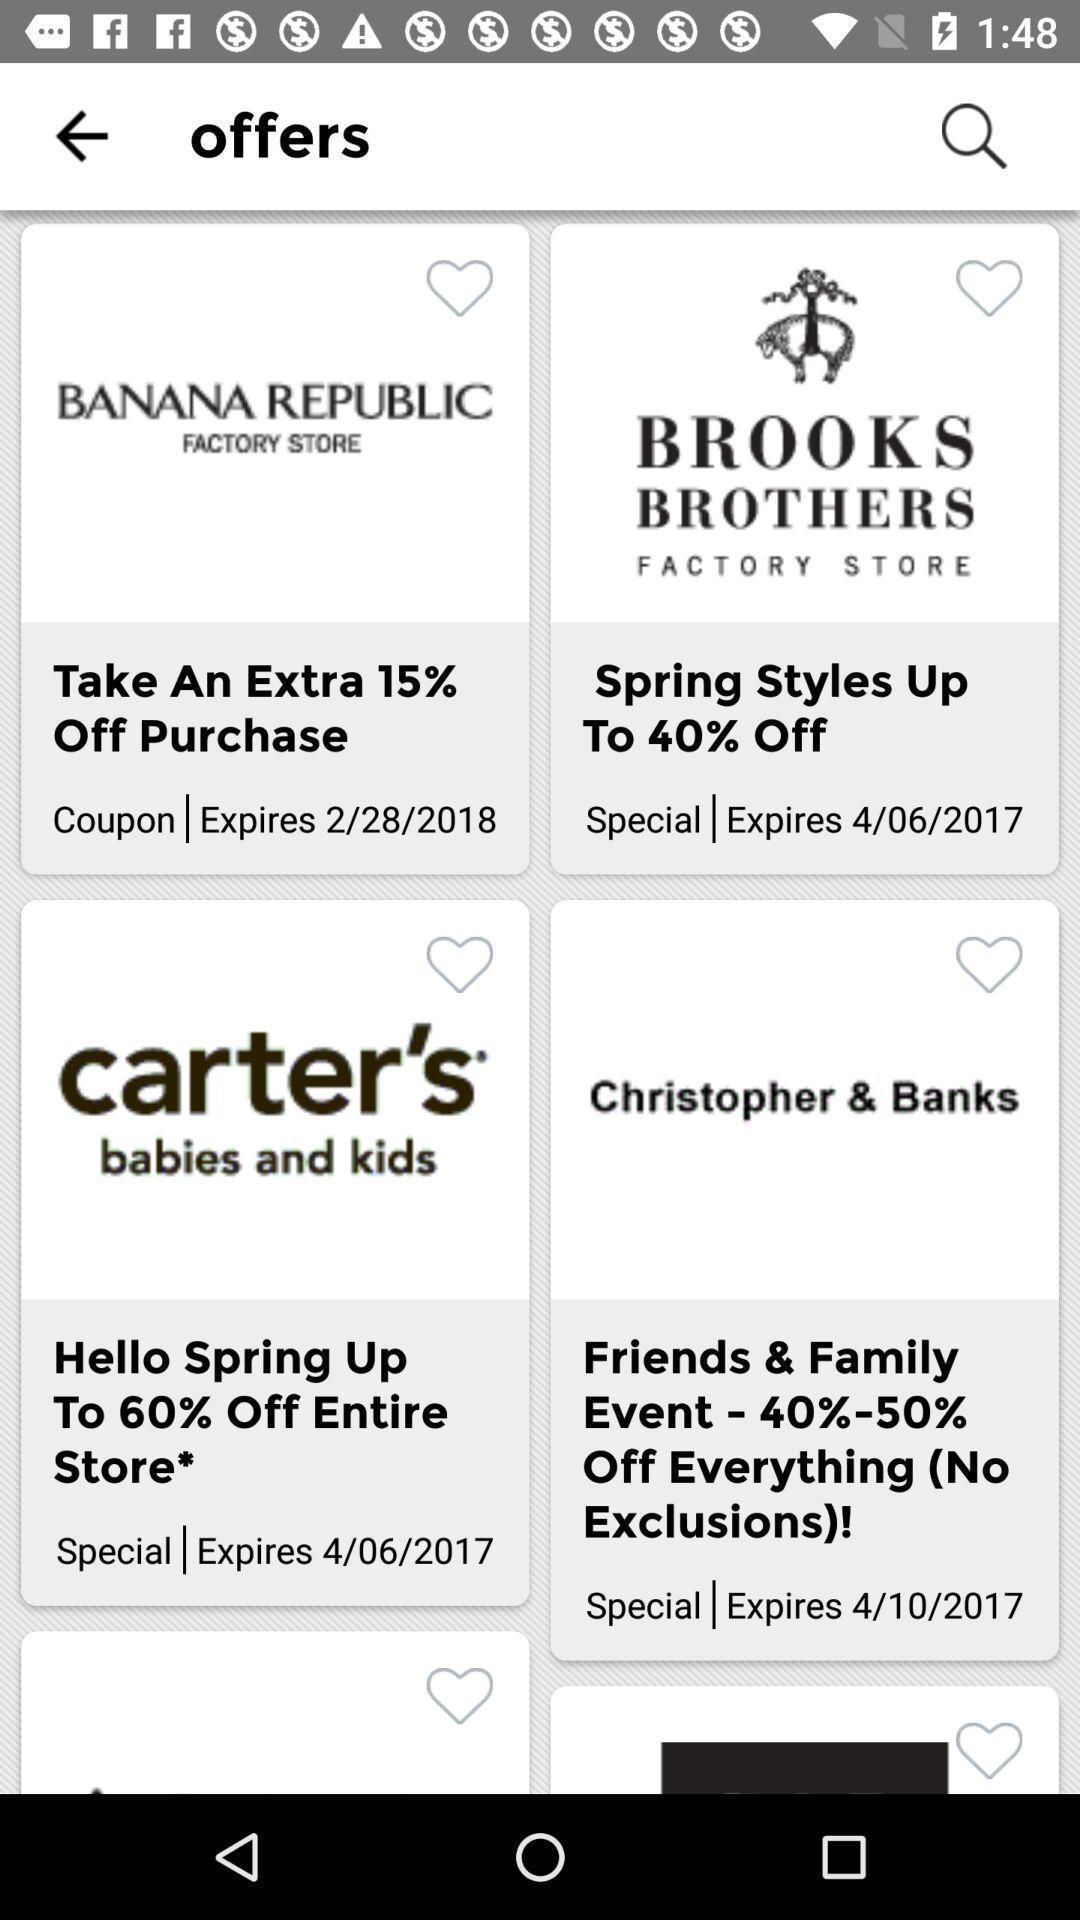Tell me what you see in this picture. Screen displaying a list of brand offers and expiration dates. 